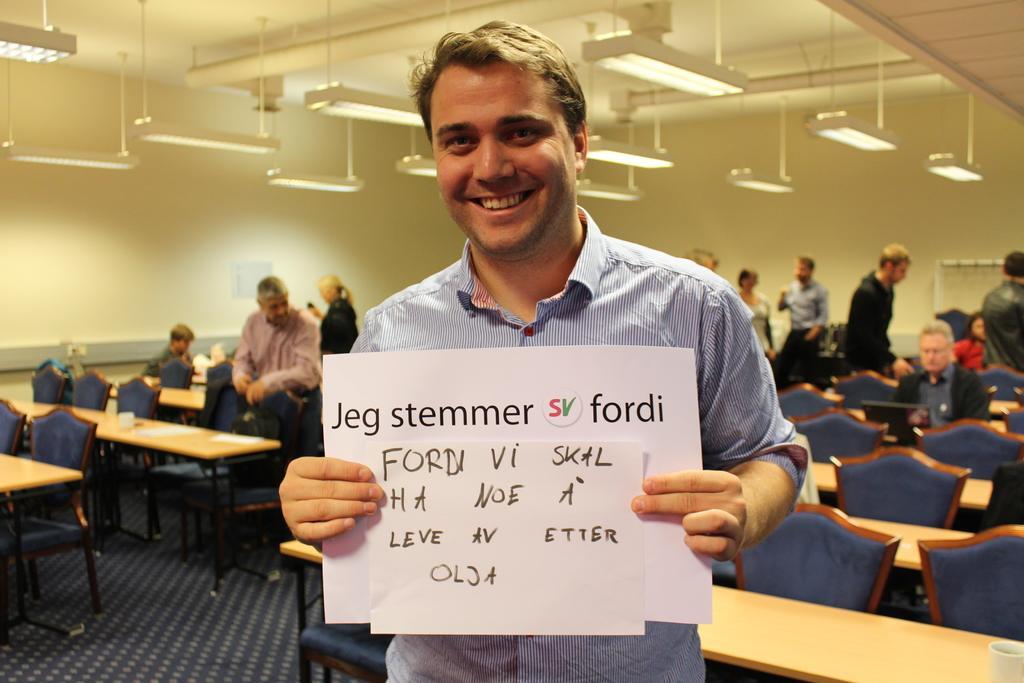In one or two sentences, can you explain what this image depicts? There is a man standing. He's smiling, holding a paper in his hands. In the background, there are some tables and chairs and some of them are standing here. We can observe a wall and some lights here. 